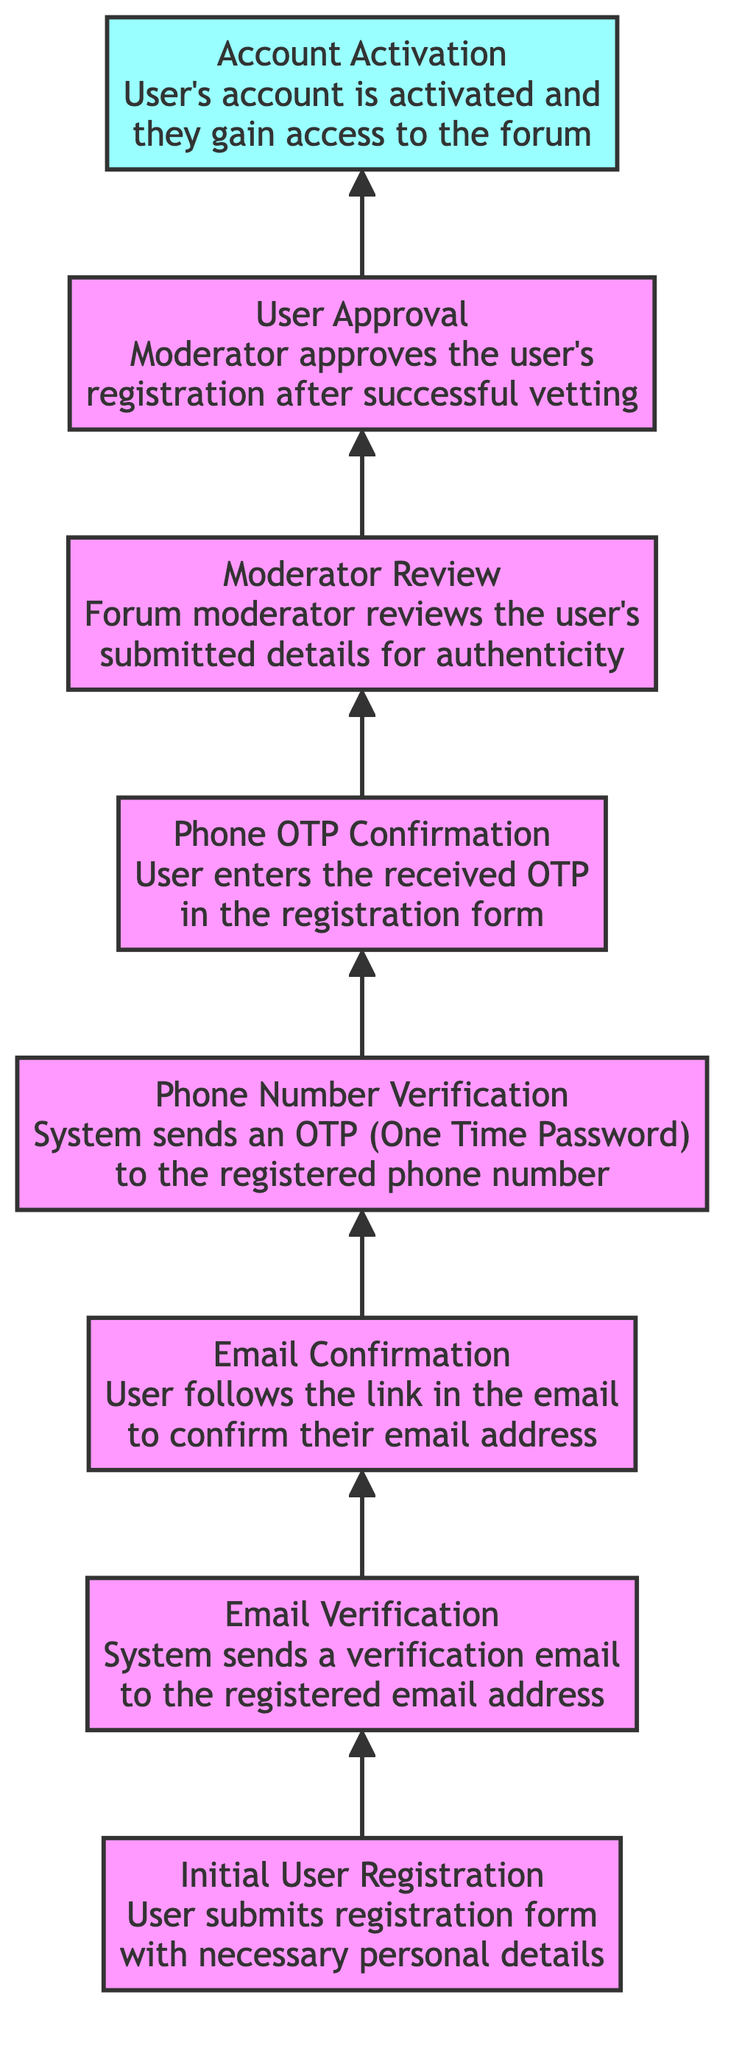What is the top node of the flow chart? The top node in a bottom-to-top flow chart is the final outcome or result of the process, which in this case is "Account Activation." Thus, it is identified as the node at the top of the chart.
Answer: Account Activation How many nodes are present in the diagram? By counting all the different steps in the user registration vetting process, we have a total of eight distinct nodes outlined in the diagram.
Answer: 8 What is the relationship between "Moderator Review" and "User Approval"? The "Moderator Review" node is directly connected to the "User Approval" node above it, indicating that the review must be completed before the approval can happen.
Answer: Directly connected What occurs directly after "Phone OTP Confirmation"? The step that follows "Phone OTP Confirmation" is "Moderator Review," which shows the progression of the registration vetting process that continues after confirming the OTP.
Answer: Moderator Review What is the first step in the registration process? The first step listed at the bottom of the flow chart is "Initial User Registration," which indicates this is where users start the process of registering for the forum.
Answer: Initial User Registration What node is immediately above "Email Confirmation"? The node that comes directly above "Email Confirmation" in the flow is "Phone Number Verification," indicating what step follows after confirming the email.
Answer: Phone Number Verification How many verification steps are there in total? The diagram outlines two verification steps: "Email Verification" and "Phone Number Verification," showing the process includes both for user registration.
Answer: 2 What must happen before "Account Activation"? Prior to "Account Activation," a series of tasks must occur, specifically, "User Approval" must take place, which signifies that the user has been vetted and approved for access.
Answer: User Approval What is the final action before a user gains forum access? The final action the user must go through before accessing the forum is "Account Activation," which indicates they have completed the registration process successfully.
Answer: Account Activation 